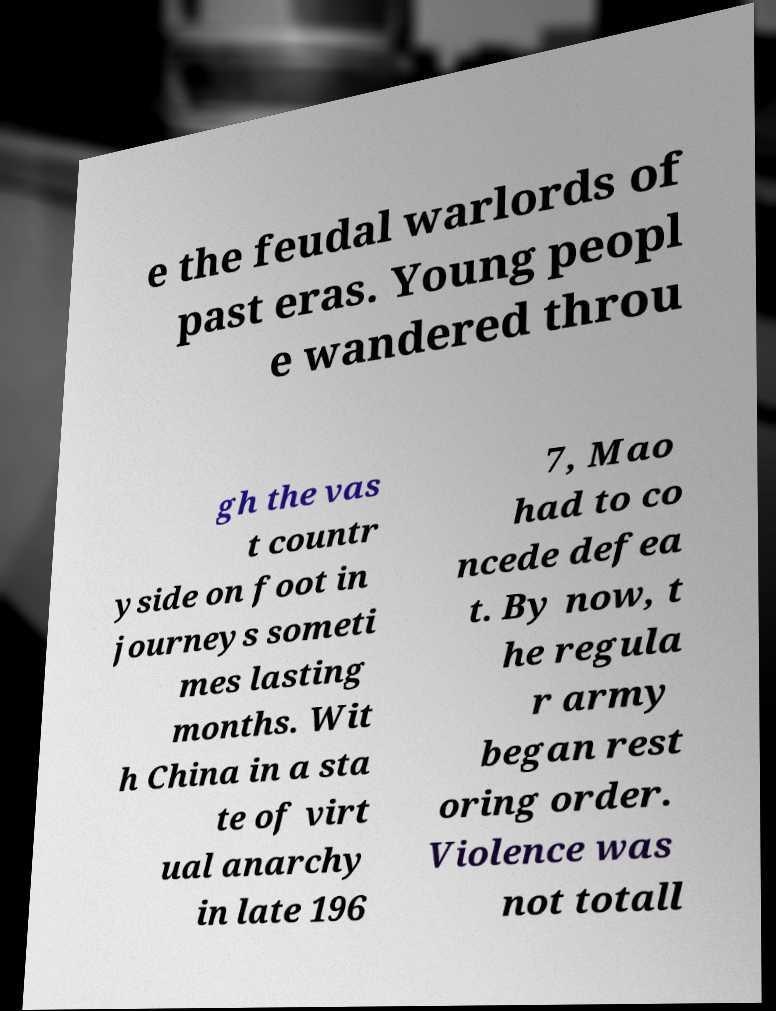What messages or text are displayed in this image? I need them in a readable, typed format. e the feudal warlords of past eras. Young peopl e wandered throu gh the vas t countr yside on foot in journeys someti mes lasting months. Wit h China in a sta te of virt ual anarchy in late 196 7, Mao had to co ncede defea t. By now, t he regula r army began rest oring order. Violence was not totall 